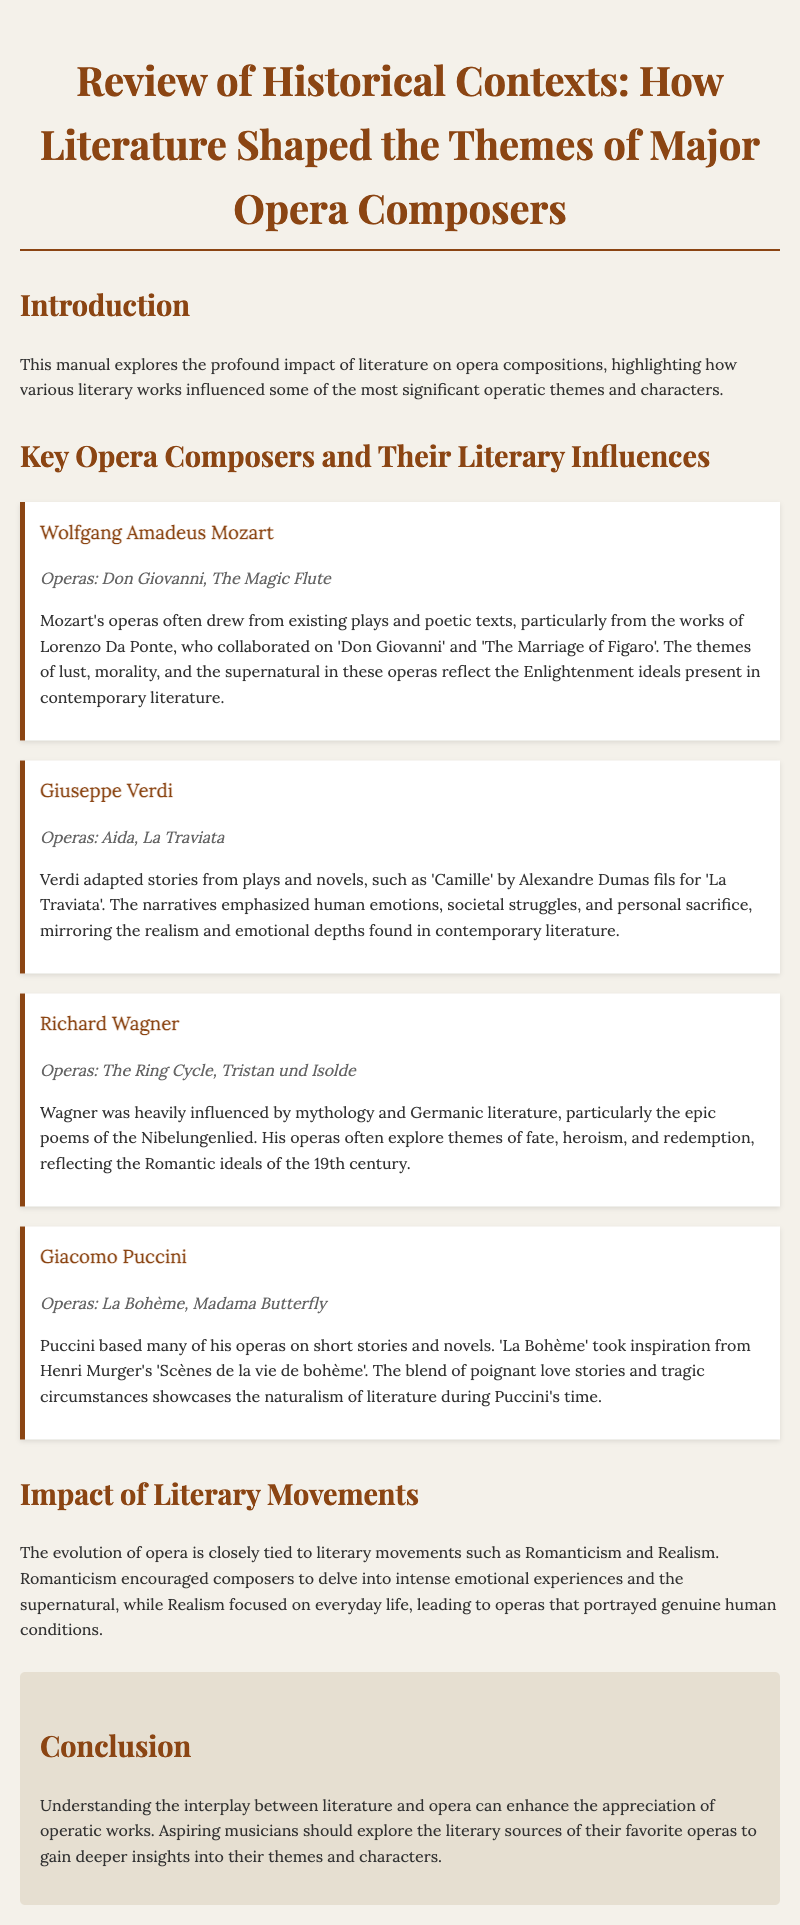What are the names of two operas by Mozart? The document lists 'Don Giovanni' and 'The Magic Flute' as operas composed by Mozart.
Answer: Don Giovanni, The Magic Flute Which literary figure collaborated with Mozart on 'Don Giovanni'? The document mentions Lorenzo Da Ponte as the collaborator for 'Don Giovanni'.
Answer: Lorenzo Da Ponte What theme is commonly reflected in Verdi's operas, as per the document? The document states that Verdi's narratives emphasized human emotions, societal struggles, and personal sacrifice.
Answer: Human emotions From which literary work is 'La Bohème' inspired? According to the document, 'La Bohème' is inspired by Henri Murger's 'Scènes de la vie de bohème'.
Answer: Scènes de la vie de bohème What literary movement influenced the intensity of emotions in opera? The document indicates that Romanticism encouraged composers to delve into intense emotional experiences.
Answer: Romanticism How many operas are mentioned under Richard Wagner? The document lists 'The Ring Cycle' and 'Tristan und Isolde' as the operas composed by Wagner.
Answer: Two What is a significant impact of Realism on opera themes? The document states that Realism focused on everyday life, leading to operas that portrayed genuine human conditions.
Answer: Genuine human conditions Which composer is known for themes of fate and heroism? The document attributes themes of fate, heroism, and redemption to Richard Wagner's operas.
Answer: Richard Wagner What genre of literature significantly shaped the themes of major opera composers? The document suggests that various literary works significantly shaped operatic themes.
Answer: Literature 